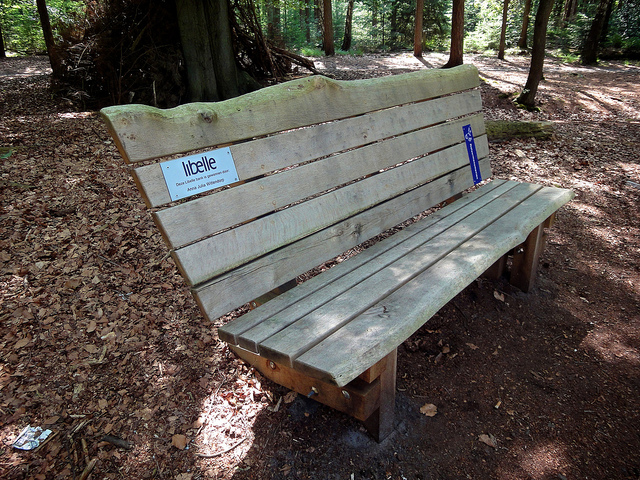Read all the text in this image. libelle 